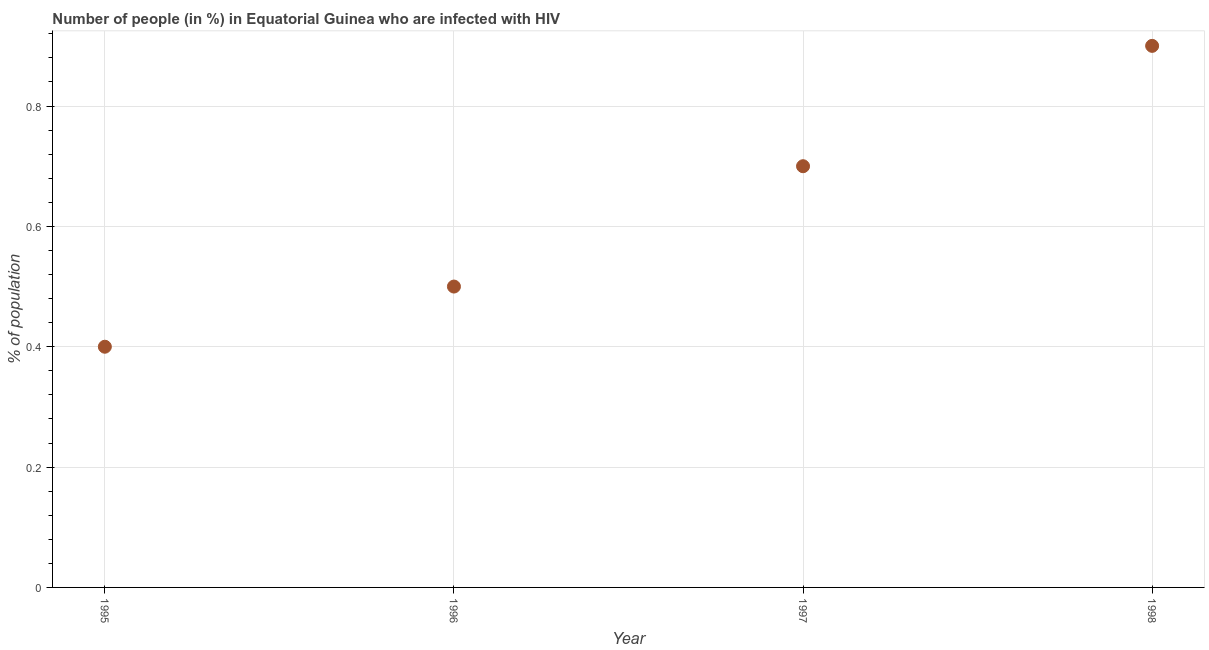What is the number of people infected with hiv in 1997?
Provide a succinct answer. 0.7. What is the sum of the number of people infected with hiv?
Offer a terse response. 2.5. What is the difference between the number of people infected with hiv in 1997 and 1998?
Your response must be concise. -0.2. What is the average number of people infected with hiv per year?
Your answer should be compact. 0.62. What is the median number of people infected with hiv?
Ensure brevity in your answer.  0.6. What is the ratio of the number of people infected with hiv in 1996 to that in 1997?
Provide a short and direct response. 0.71. Is the difference between the number of people infected with hiv in 1995 and 1997 greater than the difference between any two years?
Offer a terse response. No. What is the difference between the highest and the second highest number of people infected with hiv?
Provide a succinct answer. 0.2. Is the sum of the number of people infected with hiv in 1996 and 1997 greater than the maximum number of people infected with hiv across all years?
Offer a very short reply. Yes. In how many years, is the number of people infected with hiv greater than the average number of people infected with hiv taken over all years?
Provide a short and direct response. 2. What is the difference between two consecutive major ticks on the Y-axis?
Offer a very short reply. 0.2. Does the graph contain grids?
Offer a very short reply. Yes. What is the title of the graph?
Your answer should be compact. Number of people (in %) in Equatorial Guinea who are infected with HIV. What is the label or title of the X-axis?
Your answer should be very brief. Year. What is the label or title of the Y-axis?
Offer a very short reply. % of population. What is the % of population in 1995?
Provide a succinct answer. 0.4. What is the % of population in 1996?
Your answer should be very brief. 0.5. What is the % of population in 1997?
Offer a terse response. 0.7. What is the difference between the % of population in 1995 and 1996?
Provide a succinct answer. -0.1. What is the difference between the % of population in 1996 and 1997?
Offer a terse response. -0.2. What is the difference between the % of population in 1996 and 1998?
Ensure brevity in your answer.  -0.4. What is the ratio of the % of population in 1995 to that in 1996?
Offer a terse response. 0.8. What is the ratio of the % of population in 1995 to that in 1997?
Offer a very short reply. 0.57. What is the ratio of the % of population in 1995 to that in 1998?
Give a very brief answer. 0.44. What is the ratio of the % of population in 1996 to that in 1997?
Provide a short and direct response. 0.71. What is the ratio of the % of population in 1996 to that in 1998?
Provide a short and direct response. 0.56. What is the ratio of the % of population in 1997 to that in 1998?
Provide a succinct answer. 0.78. 